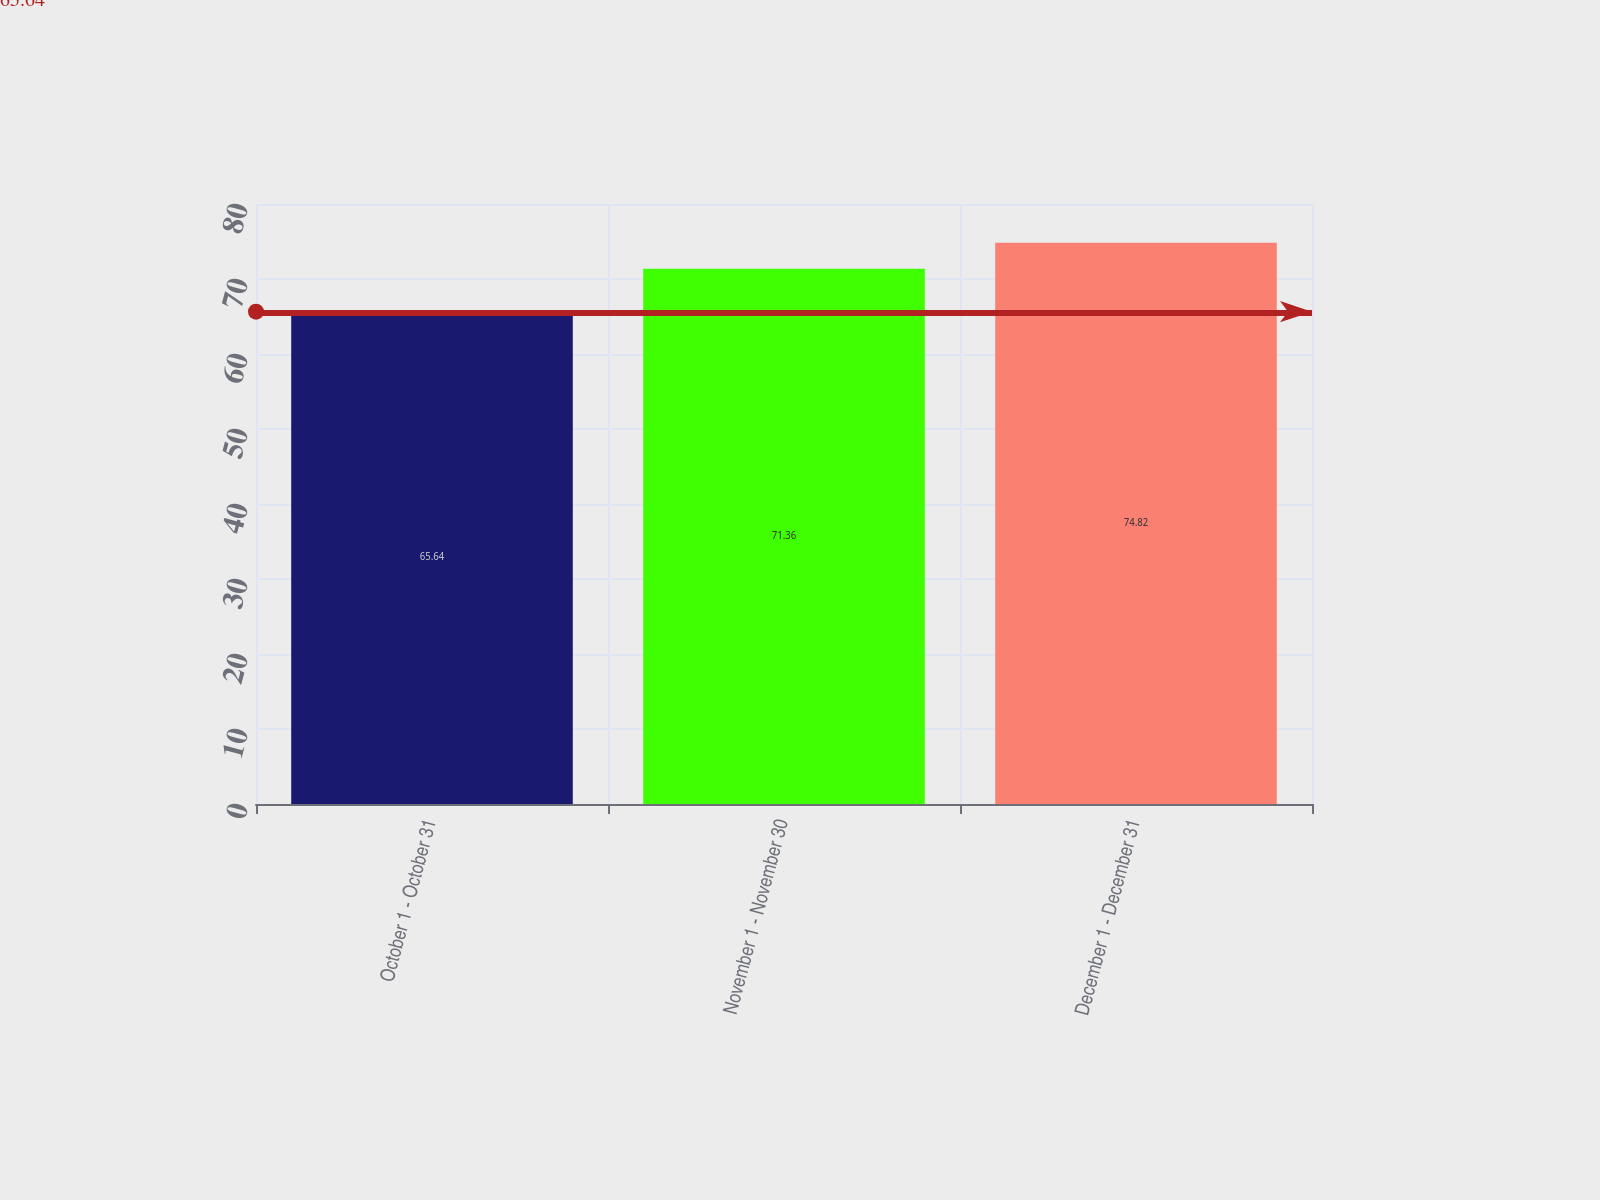<chart> <loc_0><loc_0><loc_500><loc_500><bar_chart><fcel>October 1 - October 31<fcel>November 1 - November 30<fcel>December 1 - December 31<nl><fcel>65.64<fcel>71.36<fcel>74.82<nl></chart> 